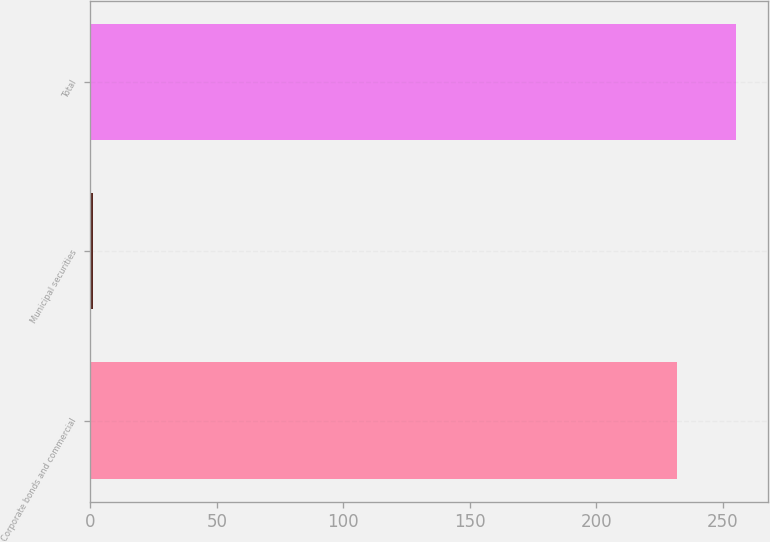Convert chart. <chart><loc_0><loc_0><loc_500><loc_500><bar_chart><fcel>Corporate bonds and commercial<fcel>Municipal securities<fcel>Total<nl><fcel>232<fcel>1<fcel>255.2<nl></chart> 